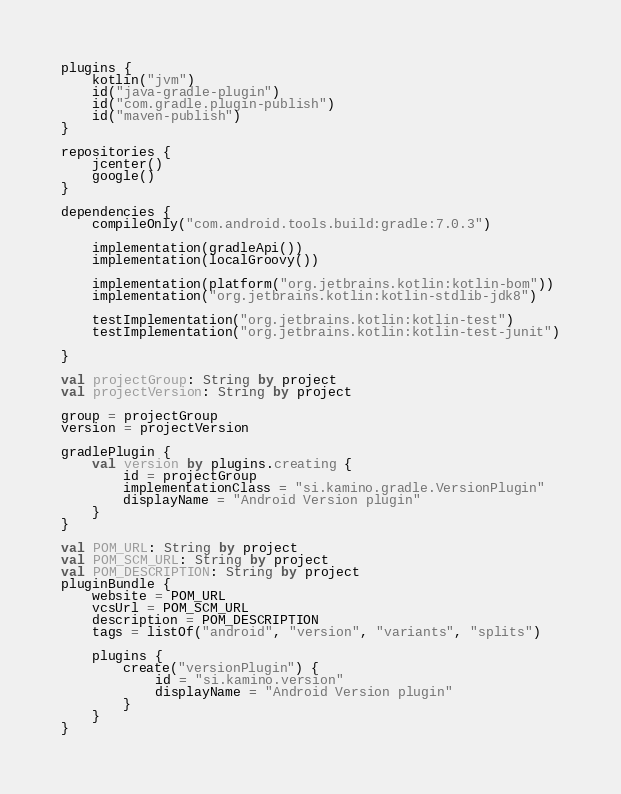<code> <loc_0><loc_0><loc_500><loc_500><_Kotlin_>plugins {
    kotlin("jvm")
    id("java-gradle-plugin")
    id("com.gradle.plugin-publish")
    id("maven-publish")
}

repositories {
    jcenter()
    google()
}

dependencies {
    compileOnly("com.android.tools.build:gradle:7.0.3")

    implementation(gradleApi())
    implementation(localGroovy())

    implementation(platform("org.jetbrains.kotlin:kotlin-bom"))
    implementation("org.jetbrains.kotlin:kotlin-stdlib-jdk8")

    testImplementation("org.jetbrains.kotlin:kotlin-test")
    testImplementation("org.jetbrains.kotlin:kotlin-test-junit")

}

val projectGroup: String by project
val projectVersion: String by project

group = projectGroup
version = projectVersion

gradlePlugin {
    val version by plugins.creating {
        id = projectGroup
        implementationClass = "si.kamino.gradle.VersionPlugin"
        displayName = "Android Version plugin"
    }
}

val POM_URL: String by project
val POM_SCM_URL: String by project
val POM_DESCRIPTION: String by project
pluginBundle {
    website = POM_URL
    vcsUrl = POM_SCM_URL
    description = POM_DESCRIPTION
    tags = listOf("android", "version", "variants", "splits")

    plugins {
        create("versionPlugin") {
            id = "si.kamino.version"
            displayName = "Android Version plugin"
        }
    }
}
</code> 